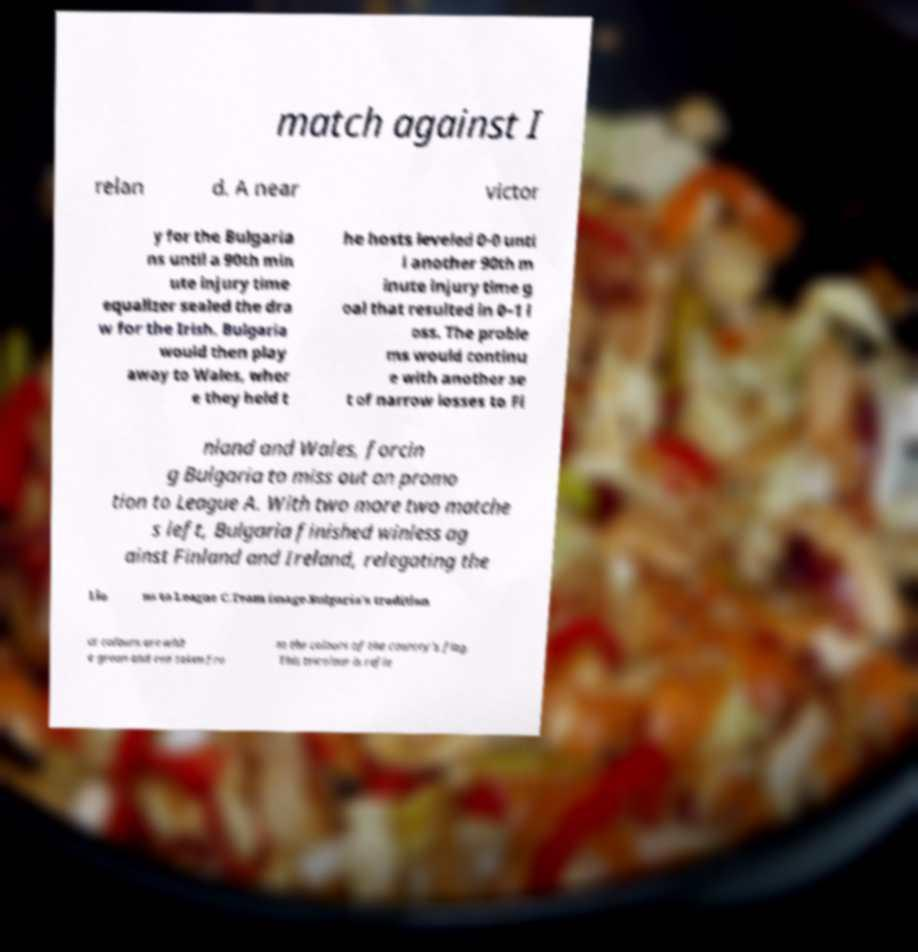What messages or text are displayed in this image? I need them in a readable, typed format. match against I relan d. A near victor y for the Bulgaria ns until a 90th min ute injury time equalizer sealed the dra w for the Irish. Bulgaria would then play away to Wales, wher e they held t he hosts leveled 0-0 unti l another 90th m inute injury time g oal that resulted in 0–1 l oss. The proble ms would continu e with another se t of narrow losses to Fi nland and Wales, forcin g Bulgaria to miss out on promo tion to League A. With two more two matche s left, Bulgaria finished winless ag ainst Finland and Ireland, relegating the Lio ns to League C.Team image.Bulgaria's tradition al colours are whit e green and red taken fro m the colours of the country's flag. This tricolour is refle 